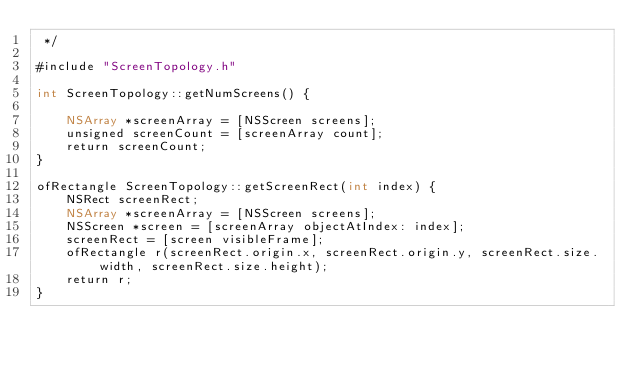<code> <loc_0><loc_0><loc_500><loc_500><_ObjectiveC_> */

#include "ScreenTopology.h"

int ScreenTopology::getNumScreens() {
    
    NSArray *screenArray = [NSScreen screens];
    unsigned screenCount = [screenArray count];
	return screenCount;
}

ofRectangle ScreenTopology::getScreenRect(int index) {
	NSRect screenRect;
	NSArray *screenArray = [NSScreen screens];
	NSScreen *screen = [screenArray objectAtIndex: index];
	screenRect = [screen visibleFrame];
    ofRectangle r(screenRect.origin.x, screenRect.origin.y, screenRect.size.width, screenRect.size.height);
	return r;
}</code> 